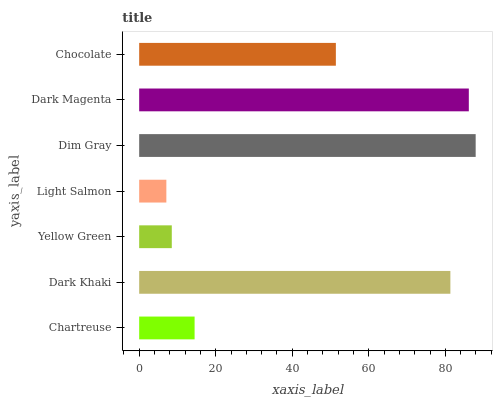Is Light Salmon the minimum?
Answer yes or no. Yes. Is Dim Gray the maximum?
Answer yes or no. Yes. Is Dark Khaki the minimum?
Answer yes or no. No. Is Dark Khaki the maximum?
Answer yes or no. No. Is Dark Khaki greater than Chartreuse?
Answer yes or no. Yes. Is Chartreuse less than Dark Khaki?
Answer yes or no. Yes. Is Chartreuse greater than Dark Khaki?
Answer yes or no. No. Is Dark Khaki less than Chartreuse?
Answer yes or no. No. Is Chocolate the high median?
Answer yes or no. Yes. Is Chocolate the low median?
Answer yes or no. Yes. Is Yellow Green the high median?
Answer yes or no. No. Is Dark Khaki the low median?
Answer yes or no. No. 